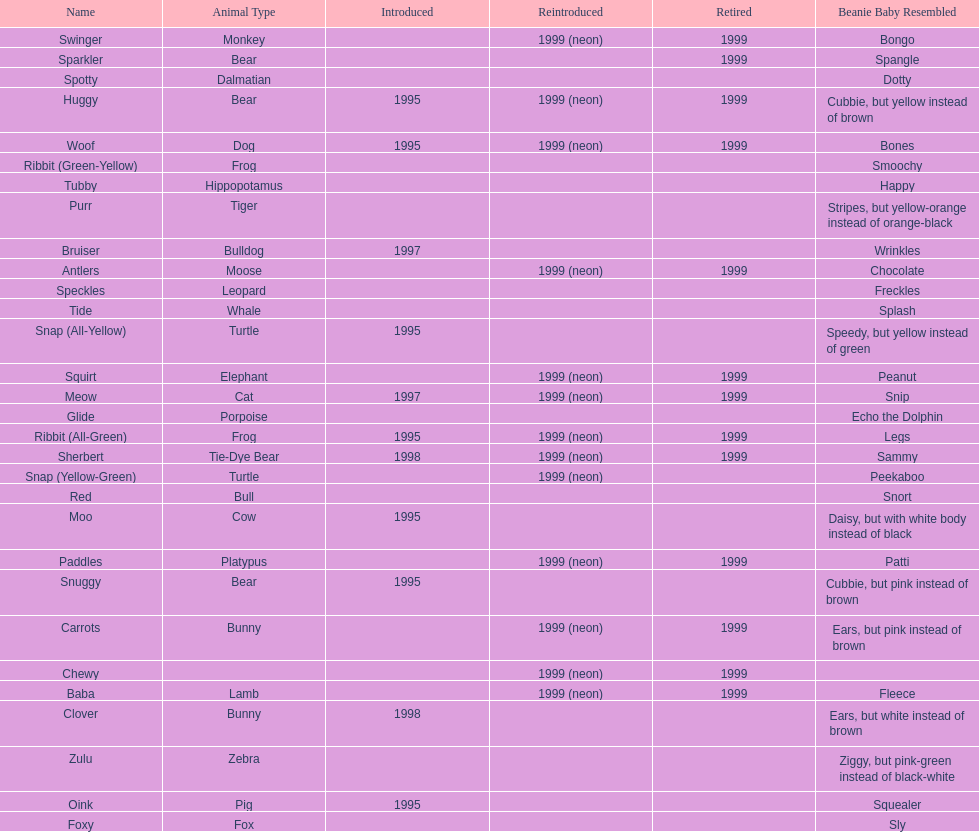In what year were the first pillow pals introduced? 1995. 